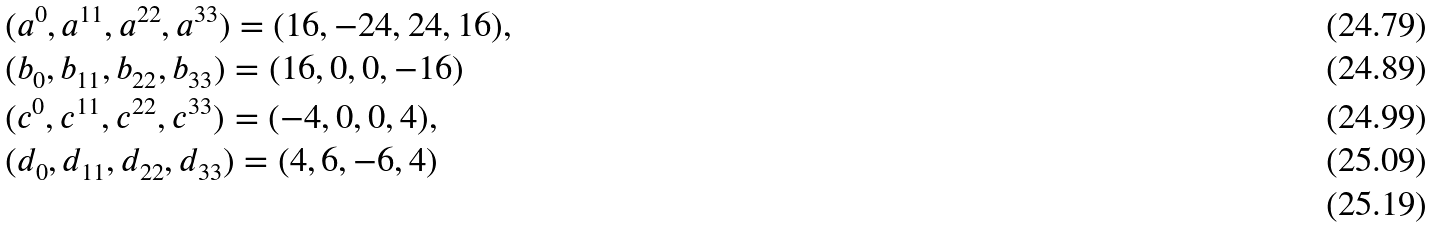<formula> <loc_0><loc_0><loc_500><loc_500>& ( a ^ { 0 } , a ^ { 1 1 } , a ^ { 2 2 } , a ^ { 3 3 } ) = ( 1 6 , - 2 4 , 2 4 , 1 6 ) , \\ & ( b _ { 0 } , b _ { 1 1 } , b _ { 2 2 } , b _ { 3 3 } ) = ( 1 6 , 0 , 0 , - 1 6 ) \\ & ( c ^ { 0 } , c ^ { 1 1 } , c ^ { 2 2 } , c ^ { 3 3 } ) = ( - 4 , 0 , 0 , 4 ) , \\ & ( d _ { 0 } , d _ { 1 1 } , d _ { 2 2 } , d _ { 3 3 } ) = ( 4 , 6 , - 6 , 4 ) \\</formula> 